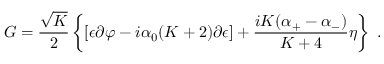<formula> <loc_0><loc_0><loc_500><loc_500>G = { \frac { \sqrt { K } } { 2 } } \left \{ [ \epsilon \partial \varphi - i { \alpha _ { 0 } } ( K + 2 ) \partial { \epsilon } ] + { \frac { i K ( { { \alpha } _ { + } } - { { \alpha } _ { - } } ) } { K + 4 } } \eta \right .</formula> 